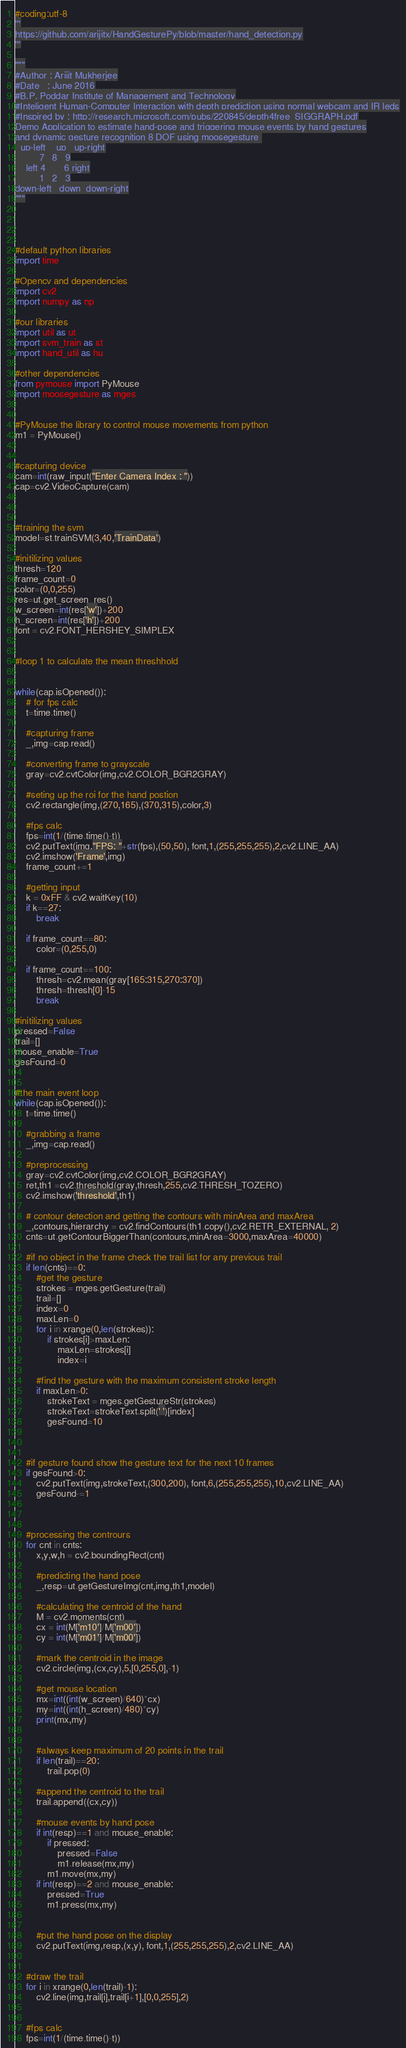<code> <loc_0><loc_0><loc_500><loc_500><_Python_>#coding:utf-8
'''
https://github.com/arijitx/HandGesturePy/blob/master/hand_detection.py
'''

"""
#Author : Arijit Mukherjee
#Date 	: June 2016
#B.P. Poddar Institute of Management and Technology
#Inteligent Human-Computer Interaction with depth prediction using normal webcam and IR leds
#Inspired by : http://research.microsoft.com/pubs/220845/depth4free_SIGGRAPH.pdf
Demo Application to estimate hand-pose and triggering mouse events by hand gestures
and dynamic gesture recognition 8 DOF using moosegesture 
  up-left    up   up-right
         7   8   9
    left 4       6 right
         1   2   3
down-left   down  down-right
"""




#default python libraries
import time

#Opencv and dependencies
import cv2
import numpy as np

#our libraries
import util as ut
import svm_train as st 
import hand_util as hu

#other dependencies
from pymouse import PyMouse
import moosegesture as mges


#PyMouse the library to control mouse movements from python
m1 = PyMouse()


#capturing device 
cam=int(raw_input("Enter Camera Index : "))
cap=cv2.VideoCapture(cam)



#training the svm 
model=st.trainSVM(3,40,'TrainData')

#initilizing values
thresh=120
frame_count=0
color=(0,0,255)
res=ut.get_screen_res()
w_screen=int(res['w'])+200
h_screen=int(res['h'])+200
font = cv2.FONT_HERSHEY_SIMPLEX


#loop 1 to calculate the mean threshhold


while(cap.isOpened()):
	# for fps calc
	t=time.time()

	#capturing frame 
	_,img=cap.read()

	#converting frame to grayscale
	gray=cv2.cvtColor(img,cv2.COLOR_BGR2GRAY)

	#seting up the roi for the hand postion
	cv2.rectangle(img,(270,165),(370,315),color,3)

	#fps calc
	fps=int(1/(time.time()-t))
	cv2.putText(img,"FPS: "+str(fps),(50,50), font,1,(255,255,255),2,cv2.LINE_AA)
	cv2.imshow('Frame',img)
	frame_count+=1

	#getting input
	k = 0xFF & cv2.waitKey(10)
	if k==27:
		break

	if frame_count==80:
		color=(0,255,0)

	if frame_count==100:
		thresh=cv2.mean(gray[165:315,270:370])
		thresh=thresh[0]-15
		break

#initilizing values
pressed=False
trail=[]
mouse_enable=True
gesFound=0


#the main event loop
while(cap.isOpened()):
	t=time.time()

	#grabbing a frame
	_,img=cap.read()

	#preprocessing
	gray=cv2.cvtColor(img,cv2.COLOR_BGR2GRAY)
	ret,th1 =cv2.threshold(gray,thresh,255,cv2.THRESH_TOZERO)
	cv2.imshow('threshold',th1)
	
	# contour detection and getting the contours with minArea and maxArea
	_,contours,hierarchy = cv2.findContours(th1.copy(),cv2.RETR_EXTERNAL, 2)
	cnts=ut.getContourBiggerThan(contours,minArea=3000,maxArea=40000)

	#if no object in the frame check the trail list for any previous trail
	if len(cnts)==0:
		#get the gesture
		strokes = mges.getGesture(trail)
		trail=[]
		index=0
		maxLen=0
		for i in xrange(0,len(strokes)):
			if strokes[i]>maxLen:
				maxLen=strokes[i]
				index=i

		#find the gesture with the maximum consistent stroke length
		if maxLen>0:
			strokeText = mges.getGestureStr(strokes)
			strokeText=strokeText.split(' ')[index]
			gesFound=10



	#if gesture found show the gesture text for the next 10 frames
	if gesFound>0:
		cv2.putText(img,strokeText,(300,200), font,6,(255,255,255),10,cv2.LINE_AA)
		gesFound-=1



	#processing the contrours
	for cnt in cnts:
		x,y,w,h = cv2.boundingRect(cnt)

		#predicting the hand pose 
		_,resp=ut.getGestureImg(cnt,img,th1,model)

		#calculating the centroid of the hand
		M = cv2.moments(cnt)
		cx = int(M['m10']/M['m00'])
		cy = int(M['m01']/M['m00'])

		#mark the centroid in the image
		cv2.circle(img,(cx,cy),5,[0,255,0],-1)

		#get mouse location
		mx=int((int(w_screen)/640)*cx)
		my=int((int(h_screen)/480)*cy)
		print(mx,my)


		#always keep maximum of 20 points in the trail
		if len(trail)==20:
			trail.pop(0)

		#append the centroid to the trail
		trail.append((cx,cy))

		#mouse events by hand pose 
		if int(resp)==1 and mouse_enable:
			if pressed:
				pressed=False
				m1.release(mx,my)
			m1.move(mx,my)
		if int(resp)==2 and mouse_enable:
			pressed=True
			m1.press(mx,my)


		#put the hand pose on the display
		cv2.putText(img,resp,(x,y), font,1,(255,255,255),2,cv2.LINE_AA)
	

	#draw the trail
	for i in xrange(0,len(trail)-1):
		cv2.line(img,trail[i],trail[i+1],[0,0,255],2)


	#fps calc
	fps=int(1/(time.time()-t))</code> 